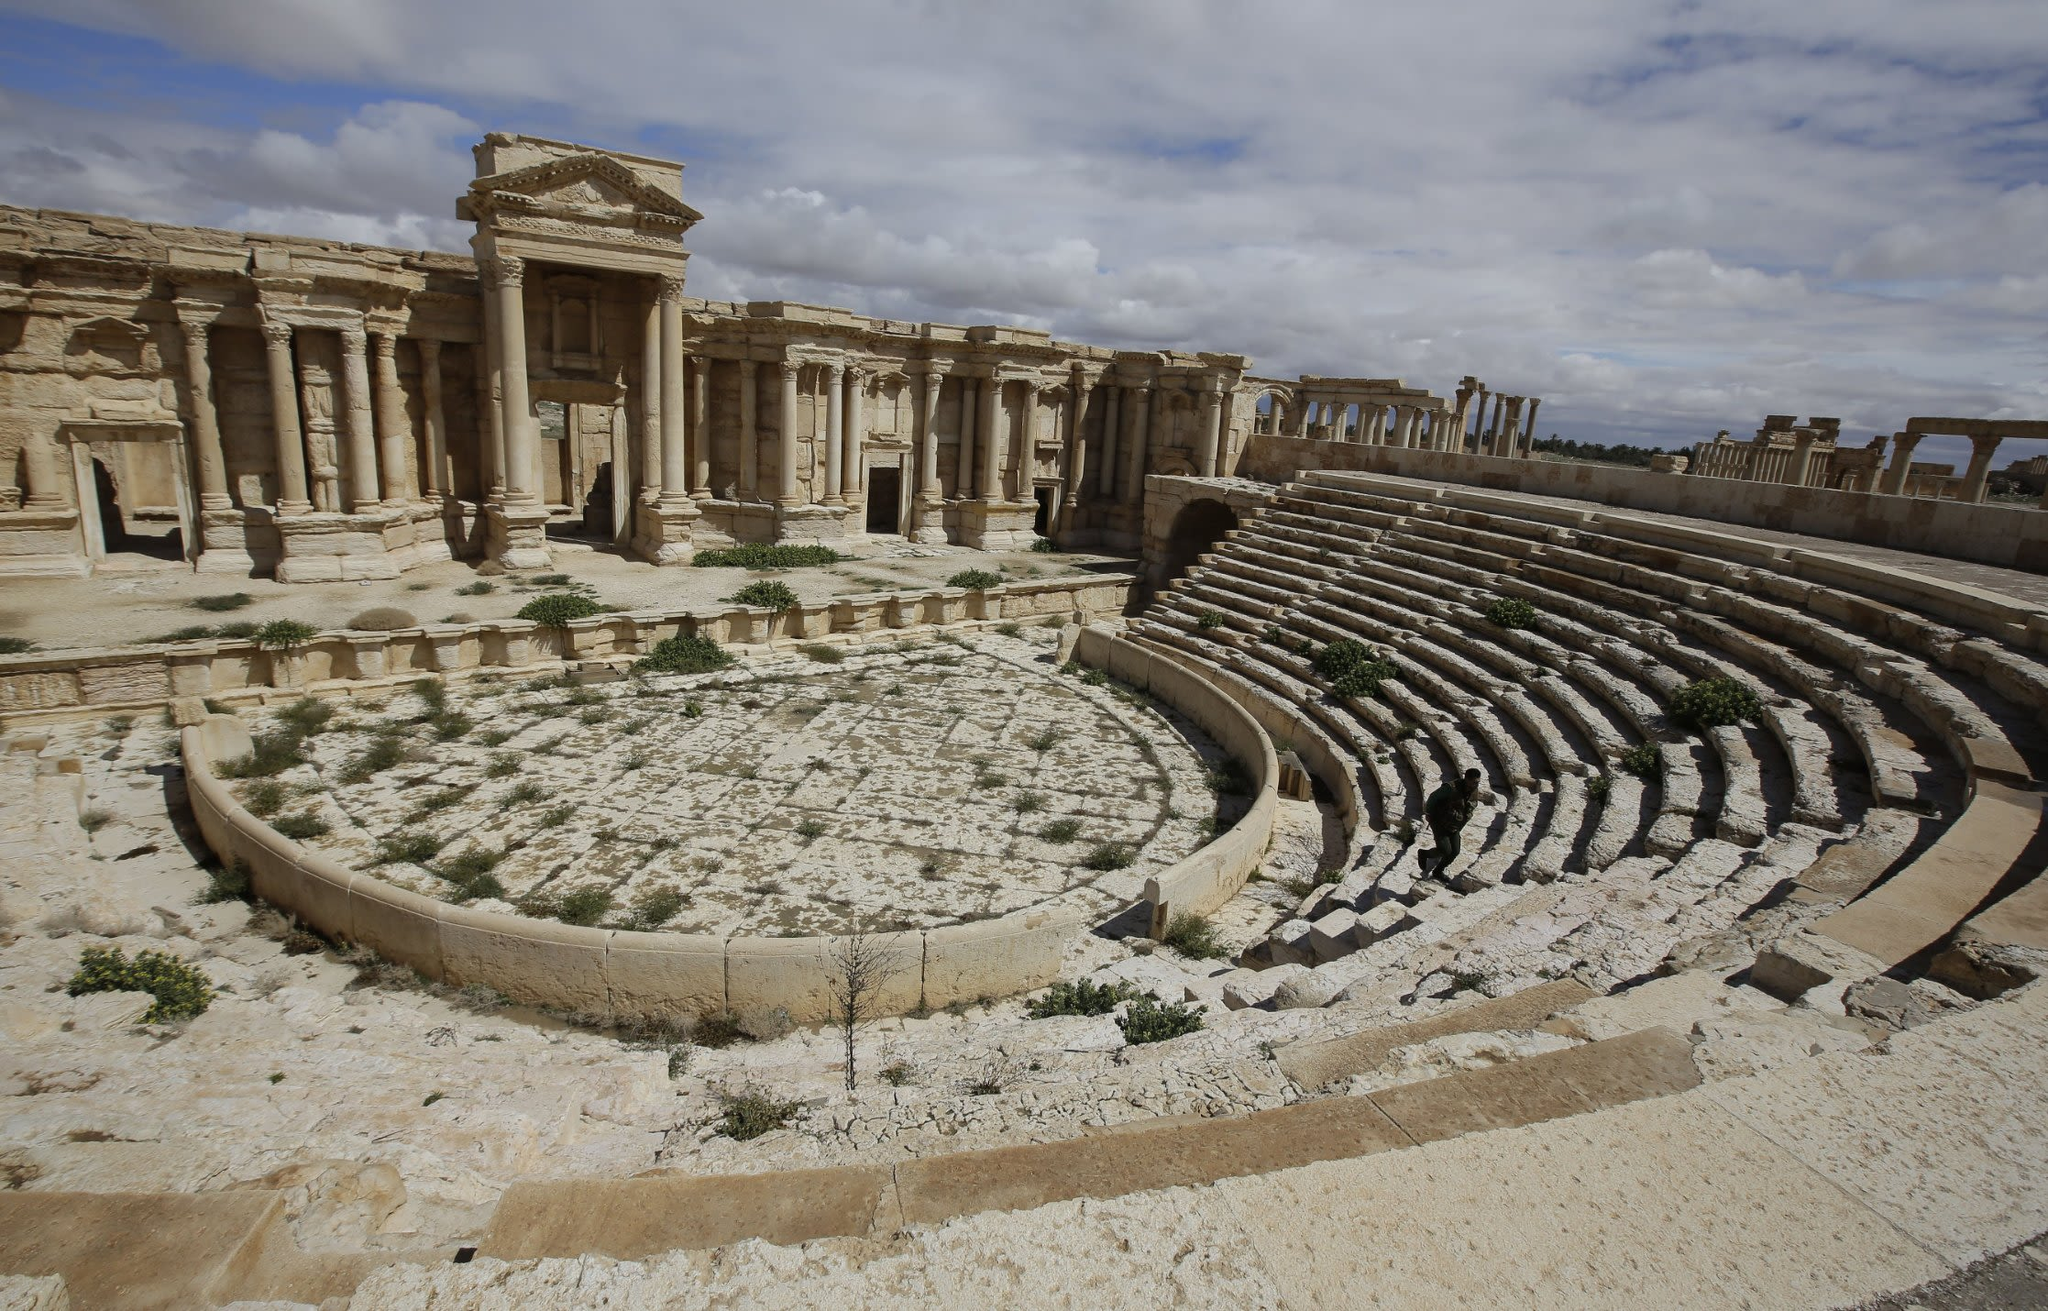Imagine a mythical creature emerging from behind the stage columns. Which creature might fit this ancient setting and what story would it bring? Emerging from behind the stage columns, a majestic griffin—a mythical creature with the body of a lion and the head and wings of an eagle—would fit this ancient setting. This griffin, a symbol of divine power and protection in both Roman and Persian mythology, would bring with it a story of ancient mystical realms. It might recount an epic tale of a lost kingdom guarded by its kind, where humans and mythical creatures coexisted in harmony until a great betrayal led to the kingdom’s downfall. Now, the griffin roams archeological ruins like this theater, seeking to share the wisdom and warnings of its bygone era, reminding modern audiences of the rich tapestry of myths that were once believed to hold real power and truth. 